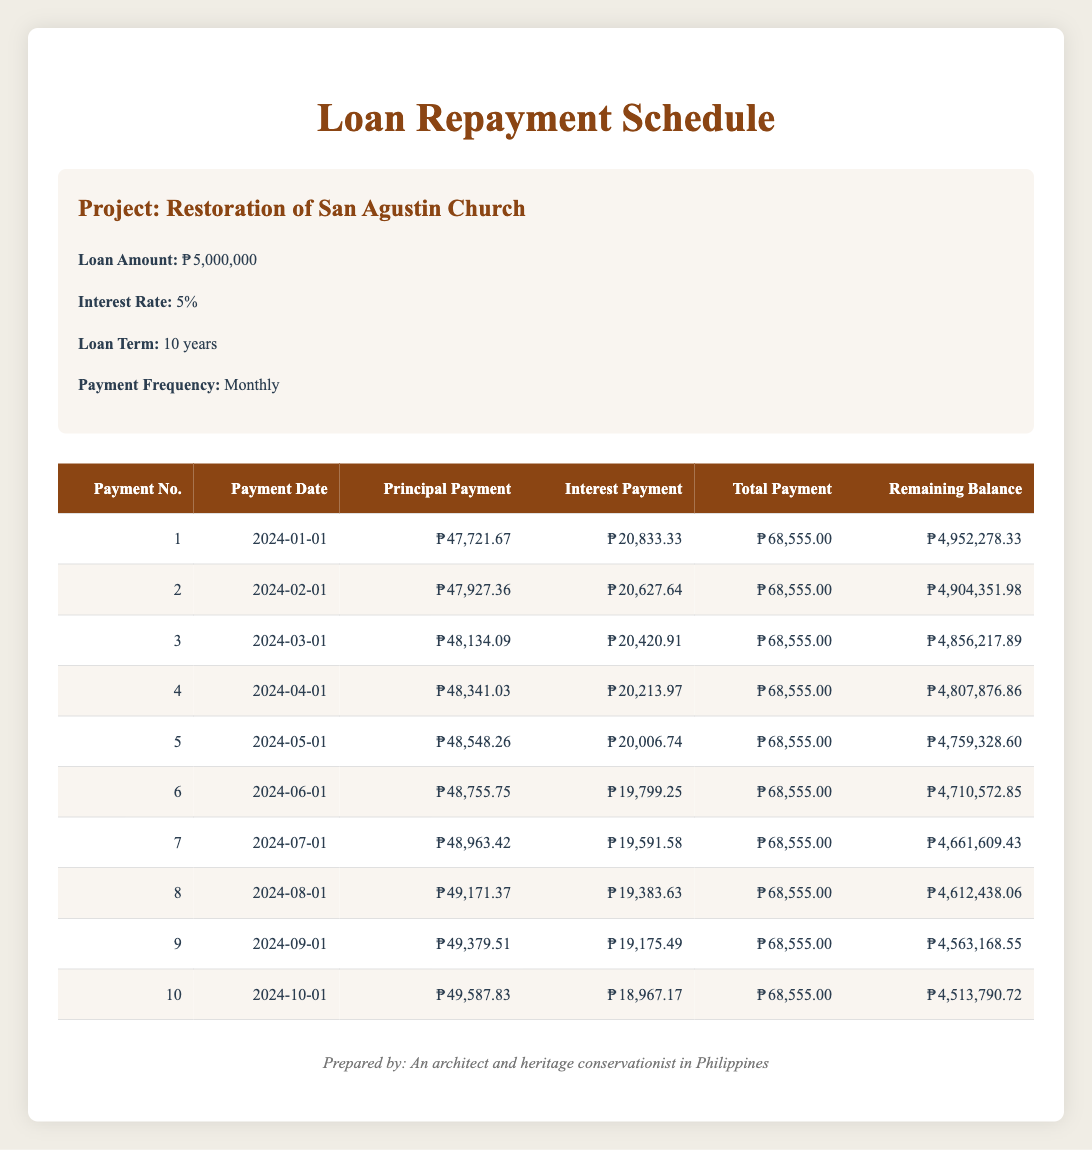What is the total loan amount for the Restoration of San Agustin Church? The loan amount is directly stated in the project details of the table as 5,000,000.
Answer: 5,000,000 How much is the total payment for the first month? The total payment for the first month is provided in the table under the "Total Payment" column for payment number 1, which is 68,555.00.
Answer: 68,555.00 What is the remaining balance after the fourth payment? The remaining balance after the fourth payment is listed in the table for payment number 4, which is 4,807,876.86.
Answer: 4,807,876.86 What is the average principal payment for the first three payments? Calculate the average principal payment by summing the principal payments for the first three payments: (47,721.67 + 47,927.36 + 48,134.09) = 143,783.12. Divide by 3 to find the average: 143,783.12 / 3 ≈ 47,927.70.
Answer: 47,927.70 Is the interest payment for the first month greater than the interest payment for the second month? The interest payment for the first month is 20,833.33 and for the second month, it is 20,627.64. Since 20,833.33 is greater than 20,627.64, the answer is yes.
Answer: Yes What is the total principal payment made by the end of the sixth month? To find the total principal payment, sum the principal payments for the first six payments: 47,721.67 + 47,927.36 + 48,134.09 + 48,341.03 + 48,548.26 + 48,755.75 = 238,428.16.
Answer: 238,428.16 What is the difference between the interest payment in the first month and the interest payment in the last month shown in the table? The interest payment in the first month is 20,833.33 and in the last month shown (the tenth payment) is 18,967.17. The difference is 20,833.33 - 18,967.17 = 1,866.16.
Answer: 1,866.16 Is the remaining balance after the third payment less than 4,800,000? The remaining balance after the third payment is 4,856,217.89, which is greater than 4,800,000, therefore the answer is no.
Answer: No How much total interest has been paid by the end of the tenth month? To find the total interest paid, sum the interest payments from months one to ten: (20,833.33 + 20,627.64 + 20,420.91 + 20,213.97 + 20,006.74 + 19,799.25 + 19,591.58 + 19,383.63 + 19,175.49 + 18,967.17) = 198,848.70.
Answer: 198,848.70 